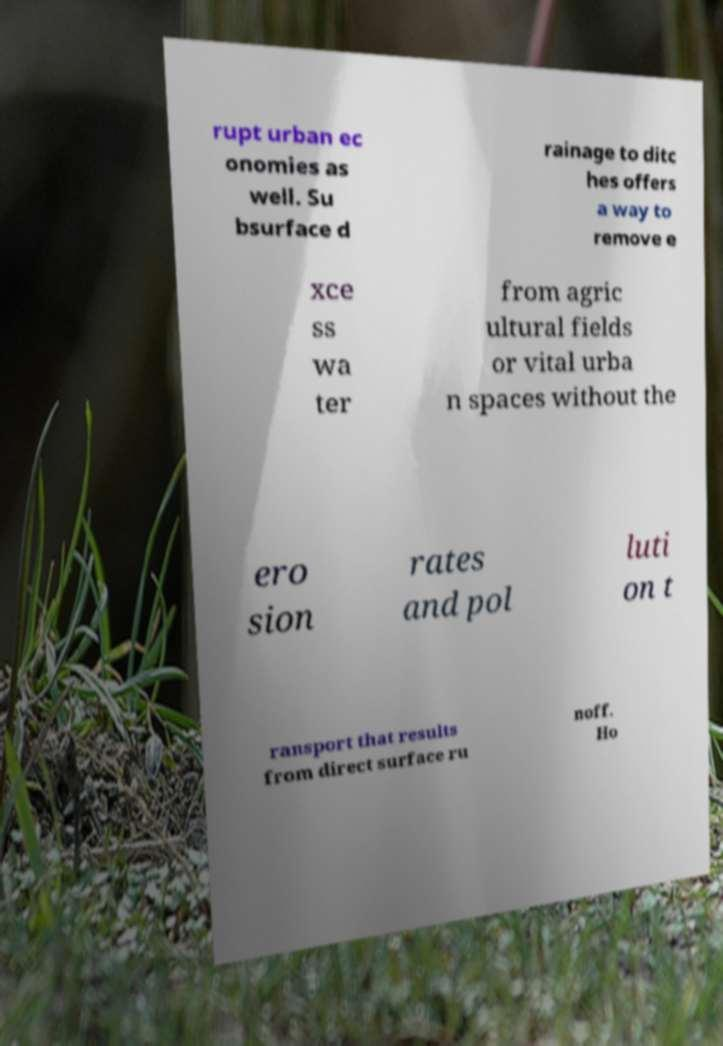Can you read and provide the text displayed in the image?This photo seems to have some interesting text. Can you extract and type it out for me? rupt urban ec onomies as well. Su bsurface d rainage to ditc hes offers a way to remove e xce ss wa ter from agric ultural fields or vital urba n spaces without the ero sion rates and pol luti on t ransport that results from direct surface ru noff. Ho 